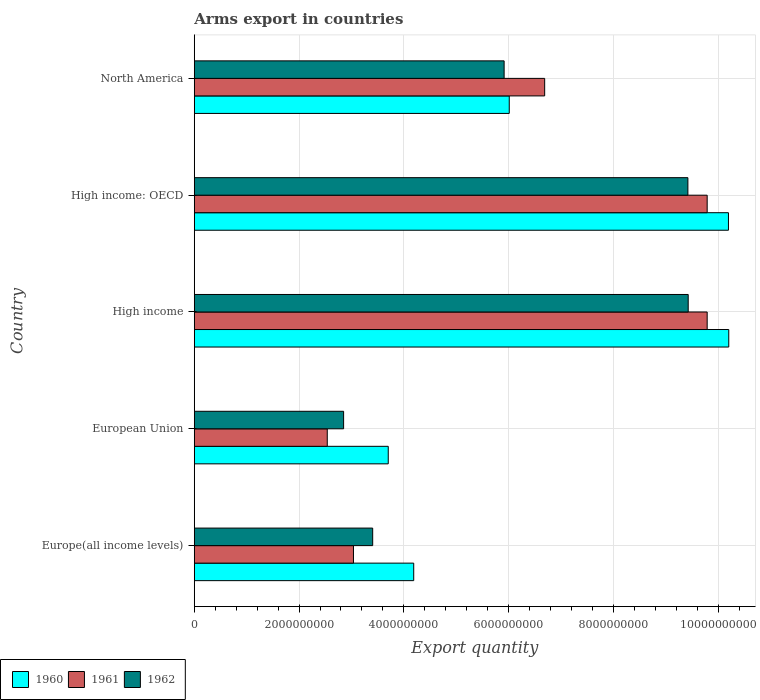How many groups of bars are there?
Your answer should be compact. 5. How many bars are there on the 1st tick from the top?
Your answer should be very brief. 3. What is the label of the 4th group of bars from the top?
Your response must be concise. European Union. In how many cases, is the number of bars for a given country not equal to the number of legend labels?
Keep it short and to the point. 0. What is the total arms export in 1962 in North America?
Provide a succinct answer. 5.91e+09. Across all countries, what is the maximum total arms export in 1961?
Your answer should be very brief. 9.79e+09. Across all countries, what is the minimum total arms export in 1961?
Provide a succinct answer. 2.54e+09. In which country was the total arms export in 1960 maximum?
Offer a terse response. High income. What is the total total arms export in 1962 in the graph?
Ensure brevity in your answer.  3.10e+1. What is the difference between the total arms export in 1960 in European Union and that in High income?
Offer a terse response. -6.50e+09. What is the difference between the total arms export in 1961 in Europe(all income levels) and the total arms export in 1960 in European Union?
Provide a succinct answer. -6.64e+08. What is the average total arms export in 1961 per country?
Ensure brevity in your answer.  6.37e+09. What is the difference between the total arms export in 1962 and total arms export in 1960 in Europe(all income levels)?
Offer a very short reply. -7.83e+08. What is the ratio of the total arms export in 1962 in European Union to that in High income?
Your answer should be very brief. 0.3. Is the difference between the total arms export in 1962 in Europe(all income levels) and High income: OECD greater than the difference between the total arms export in 1960 in Europe(all income levels) and High income: OECD?
Your response must be concise. No. What is the difference between the highest and the second highest total arms export in 1961?
Ensure brevity in your answer.  0. What is the difference between the highest and the lowest total arms export in 1960?
Ensure brevity in your answer.  6.50e+09. What does the 1st bar from the top in European Union represents?
Make the answer very short. 1962. What does the 1st bar from the bottom in European Union represents?
Your answer should be very brief. 1960. Is it the case that in every country, the sum of the total arms export in 1960 and total arms export in 1961 is greater than the total arms export in 1962?
Your response must be concise. Yes. How many bars are there?
Your answer should be compact. 15. Are all the bars in the graph horizontal?
Your answer should be very brief. Yes. What is the difference between two consecutive major ticks on the X-axis?
Your response must be concise. 2.00e+09. How are the legend labels stacked?
Your response must be concise. Horizontal. What is the title of the graph?
Provide a succinct answer. Arms export in countries. What is the label or title of the X-axis?
Offer a very short reply. Export quantity. What is the Export quantity in 1960 in Europe(all income levels)?
Make the answer very short. 4.19e+09. What is the Export quantity of 1961 in Europe(all income levels)?
Offer a terse response. 3.04e+09. What is the Export quantity of 1962 in Europe(all income levels)?
Offer a terse response. 3.40e+09. What is the Export quantity of 1960 in European Union?
Your answer should be compact. 3.70e+09. What is the Export quantity of 1961 in European Union?
Offer a very short reply. 2.54e+09. What is the Export quantity of 1962 in European Union?
Provide a succinct answer. 2.85e+09. What is the Export quantity in 1960 in High income?
Keep it short and to the point. 1.02e+1. What is the Export quantity of 1961 in High income?
Your answer should be very brief. 9.79e+09. What is the Export quantity in 1962 in High income?
Make the answer very short. 9.43e+09. What is the Export quantity of 1960 in High income: OECD?
Your response must be concise. 1.02e+1. What is the Export quantity in 1961 in High income: OECD?
Give a very brief answer. 9.79e+09. What is the Export quantity of 1962 in High income: OECD?
Your answer should be very brief. 9.42e+09. What is the Export quantity of 1960 in North America?
Your response must be concise. 6.01e+09. What is the Export quantity in 1961 in North America?
Your answer should be compact. 6.69e+09. What is the Export quantity in 1962 in North America?
Provide a succinct answer. 5.91e+09. Across all countries, what is the maximum Export quantity in 1960?
Keep it short and to the point. 1.02e+1. Across all countries, what is the maximum Export quantity in 1961?
Provide a short and direct response. 9.79e+09. Across all countries, what is the maximum Export quantity of 1962?
Your response must be concise. 9.43e+09. Across all countries, what is the minimum Export quantity in 1960?
Make the answer very short. 3.70e+09. Across all countries, what is the minimum Export quantity in 1961?
Provide a short and direct response. 2.54e+09. Across all countries, what is the minimum Export quantity in 1962?
Your answer should be very brief. 2.85e+09. What is the total Export quantity in 1960 in the graph?
Make the answer very short. 3.43e+1. What is the total Export quantity of 1961 in the graph?
Your response must be concise. 3.18e+1. What is the total Export quantity of 1962 in the graph?
Provide a short and direct response. 3.10e+1. What is the difference between the Export quantity in 1960 in Europe(all income levels) and that in European Union?
Ensure brevity in your answer.  4.86e+08. What is the difference between the Export quantity in 1962 in Europe(all income levels) and that in European Union?
Your answer should be very brief. 5.55e+08. What is the difference between the Export quantity in 1960 in Europe(all income levels) and that in High income?
Provide a succinct answer. -6.01e+09. What is the difference between the Export quantity of 1961 in Europe(all income levels) and that in High income?
Your answer should be compact. -6.75e+09. What is the difference between the Export quantity of 1962 in Europe(all income levels) and that in High income?
Give a very brief answer. -6.02e+09. What is the difference between the Export quantity in 1960 in Europe(all income levels) and that in High income: OECD?
Offer a very short reply. -6.01e+09. What is the difference between the Export quantity in 1961 in Europe(all income levels) and that in High income: OECD?
Your answer should be very brief. -6.75e+09. What is the difference between the Export quantity in 1962 in Europe(all income levels) and that in High income: OECD?
Your answer should be compact. -6.02e+09. What is the difference between the Export quantity in 1960 in Europe(all income levels) and that in North America?
Offer a terse response. -1.82e+09. What is the difference between the Export quantity in 1961 in Europe(all income levels) and that in North America?
Keep it short and to the point. -3.65e+09. What is the difference between the Export quantity of 1962 in Europe(all income levels) and that in North America?
Provide a short and direct response. -2.51e+09. What is the difference between the Export quantity in 1960 in European Union and that in High income?
Your response must be concise. -6.50e+09. What is the difference between the Export quantity of 1961 in European Union and that in High income?
Your answer should be compact. -7.25e+09. What is the difference between the Export quantity in 1962 in European Union and that in High income?
Your answer should be very brief. -6.58e+09. What is the difference between the Export quantity of 1960 in European Union and that in High income: OECD?
Your answer should be compact. -6.49e+09. What is the difference between the Export quantity in 1961 in European Union and that in High income: OECD?
Provide a short and direct response. -7.25e+09. What is the difference between the Export quantity in 1962 in European Union and that in High income: OECD?
Give a very brief answer. -6.57e+09. What is the difference between the Export quantity in 1960 in European Union and that in North America?
Provide a succinct answer. -2.31e+09. What is the difference between the Export quantity in 1961 in European Union and that in North America?
Your answer should be compact. -4.15e+09. What is the difference between the Export quantity of 1962 in European Union and that in North America?
Offer a very short reply. -3.06e+09. What is the difference between the Export quantity of 1960 in High income and that in High income: OECD?
Offer a terse response. 6.00e+06. What is the difference between the Export quantity of 1960 in High income and that in North America?
Your answer should be compact. 4.19e+09. What is the difference between the Export quantity of 1961 in High income and that in North America?
Offer a very short reply. 3.10e+09. What is the difference between the Export quantity of 1962 in High income and that in North America?
Your answer should be compact. 3.51e+09. What is the difference between the Export quantity in 1960 in High income: OECD and that in North America?
Give a very brief answer. 4.18e+09. What is the difference between the Export quantity in 1961 in High income: OECD and that in North America?
Keep it short and to the point. 3.10e+09. What is the difference between the Export quantity of 1962 in High income: OECD and that in North America?
Keep it short and to the point. 3.51e+09. What is the difference between the Export quantity in 1960 in Europe(all income levels) and the Export quantity in 1961 in European Union?
Your answer should be compact. 1.65e+09. What is the difference between the Export quantity of 1960 in Europe(all income levels) and the Export quantity of 1962 in European Union?
Provide a succinct answer. 1.34e+09. What is the difference between the Export quantity in 1961 in Europe(all income levels) and the Export quantity in 1962 in European Union?
Provide a short and direct response. 1.88e+08. What is the difference between the Export quantity of 1960 in Europe(all income levels) and the Export quantity of 1961 in High income?
Provide a succinct answer. -5.60e+09. What is the difference between the Export quantity of 1960 in Europe(all income levels) and the Export quantity of 1962 in High income?
Keep it short and to the point. -5.24e+09. What is the difference between the Export quantity of 1961 in Europe(all income levels) and the Export quantity of 1962 in High income?
Offer a terse response. -6.39e+09. What is the difference between the Export quantity of 1960 in Europe(all income levels) and the Export quantity of 1961 in High income: OECD?
Your answer should be compact. -5.60e+09. What is the difference between the Export quantity of 1960 in Europe(all income levels) and the Export quantity of 1962 in High income: OECD?
Offer a terse response. -5.23e+09. What is the difference between the Export quantity of 1961 in Europe(all income levels) and the Export quantity of 1962 in High income: OECD?
Your answer should be compact. -6.38e+09. What is the difference between the Export quantity in 1960 in Europe(all income levels) and the Export quantity in 1961 in North America?
Ensure brevity in your answer.  -2.50e+09. What is the difference between the Export quantity in 1960 in Europe(all income levels) and the Export quantity in 1962 in North America?
Your answer should be very brief. -1.72e+09. What is the difference between the Export quantity in 1961 in Europe(all income levels) and the Export quantity in 1962 in North America?
Provide a short and direct response. -2.88e+09. What is the difference between the Export quantity of 1960 in European Union and the Export quantity of 1961 in High income?
Your answer should be compact. -6.09e+09. What is the difference between the Export quantity in 1960 in European Union and the Export quantity in 1962 in High income?
Provide a short and direct response. -5.72e+09. What is the difference between the Export quantity of 1961 in European Union and the Export quantity of 1962 in High income?
Your answer should be very brief. -6.89e+09. What is the difference between the Export quantity in 1960 in European Union and the Export quantity in 1961 in High income: OECD?
Offer a very short reply. -6.09e+09. What is the difference between the Export quantity of 1960 in European Union and the Export quantity of 1962 in High income: OECD?
Provide a succinct answer. -5.72e+09. What is the difference between the Export quantity of 1961 in European Union and the Export quantity of 1962 in High income: OECD?
Offer a terse response. -6.88e+09. What is the difference between the Export quantity of 1960 in European Union and the Export quantity of 1961 in North America?
Your answer should be compact. -2.98e+09. What is the difference between the Export quantity in 1960 in European Union and the Export quantity in 1962 in North America?
Keep it short and to the point. -2.21e+09. What is the difference between the Export quantity of 1961 in European Union and the Export quantity of 1962 in North America?
Offer a very short reply. -3.38e+09. What is the difference between the Export quantity of 1960 in High income and the Export quantity of 1961 in High income: OECD?
Keep it short and to the point. 4.12e+08. What is the difference between the Export quantity in 1960 in High income and the Export quantity in 1962 in High income: OECD?
Provide a short and direct response. 7.80e+08. What is the difference between the Export quantity of 1961 in High income and the Export quantity of 1962 in High income: OECD?
Offer a very short reply. 3.68e+08. What is the difference between the Export quantity of 1960 in High income and the Export quantity of 1961 in North America?
Your answer should be very brief. 3.51e+09. What is the difference between the Export quantity of 1960 in High income and the Export quantity of 1962 in North America?
Ensure brevity in your answer.  4.29e+09. What is the difference between the Export quantity in 1961 in High income and the Export quantity in 1962 in North America?
Provide a succinct answer. 3.88e+09. What is the difference between the Export quantity in 1960 in High income: OECD and the Export quantity in 1961 in North America?
Your answer should be compact. 3.51e+09. What is the difference between the Export quantity in 1960 in High income: OECD and the Export quantity in 1962 in North America?
Make the answer very short. 4.28e+09. What is the difference between the Export quantity of 1961 in High income: OECD and the Export quantity of 1962 in North America?
Make the answer very short. 3.88e+09. What is the average Export quantity of 1960 per country?
Your response must be concise. 6.86e+09. What is the average Export quantity of 1961 per country?
Your response must be concise. 6.37e+09. What is the average Export quantity of 1962 per country?
Your answer should be very brief. 6.20e+09. What is the difference between the Export quantity of 1960 and Export quantity of 1961 in Europe(all income levels)?
Offer a terse response. 1.15e+09. What is the difference between the Export quantity in 1960 and Export quantity in 1962 in Europe(all income levels)?
Your answer should be very brief. 7.83e+08. What is the difference between the Export quantity in 1961 and Export quantity in 1962 in Europe(all income levels)?
Keep it short and to the point. -3.67e+08. What is the difference between the Export quantity in 1960 and Export quantity in 1961 in European Union?
Ensure brevity in your answer.  1.16e+09. What is the difference between the Export quantity of 1960 and Export quantity of 1962 in European Union?
Ensure brevity in your answer.  8.52e+08. What is the difference between the Export quantity of 1961 and Export quantity of 1962 in European Union?
Your answer should be compact. -3.12e+08. What is the difference between the Export quantity in 1960 and Export quantity in 1961 in High income?
Make the answer very short. 4.12e+08. What is the difference between the Export quantity in 1960 and Export quantity in 1962 in High income?
Give a very brief answer. 7.74e+08. What is the difference between the Export quantity of 1961 and Export quantity of 1962 in High income?
Offer a very short reply. 3.62e+08. What is the difference between the Export quantity in 1960 and Export quantity in 1961 in High income: OECD?
Make the answer very short. 4.06e+08. What is the difference between the Export quantity in 1960 and Export quantity in 1962 in High income: OECD?
Provide a short and direct response. 7.74e+08. What is the difference between the Export quantity of 1961 and Export quantity of 1962 in High income: OECD?
Ensure brevity in your answer.  3.68e+08. What is the difference between the Export quantity in 1960 and Export quantity in 1961 in North America?
Your answer should be compact. -6.76e+08. What is the difference between the Export quantity in 1960 and Export quantity in 1962 in North America?
Your response must be concise. 9.80e+07. What is the difference between the Export quantity in 1961 and Export quantity in 1962 in North America?
Your response must be concise. 7.74e+08. What is the ratio of the Export quantity of 1960 in Europe(all income levels) to that in European Union?
Your answer should be very brief. 1.13. What is the ratio of the Export quantity of 1961 in Europe(all income levels) to that in European Union?
Make the answer very short. 1.2. What is the ratio of the Export quantity in 1962 in Europe(all income levels) to that in European Union?
Your answer should be compact. 1.19. What is the ratio of the Export quantity of 1960 in Europe(all income levels) to that in High income?
Your answer should be compact. 0.41. What is the ratio of the Export quantity of 1961 in Europe(all income levels) to that in High income?
Your answer should be very brief. 0.31. What is the ratio of the Export quantity in 1962 in Europe(all income levels) to that in High income?
Provide a short and direct response. 0.36. What is the ratio of the Export quantity of 1960 in Europe(all income levels) to that in High income: OECD?
Ensure brevity in your answer.  0.41. What is the ratio of the Export quantity of 1961 in Europe(all income levels) to that in High income: OECD?
Make the answer very short. 0.31. What is the ratio of the Export quantity of 1962 in Europe(all income levels) to that in High income: OECD?
Make the answer very short. 0.36. What is the ratio of the Export quantity in 1960 in Europe(all income levels) to that in North America?
Your answer should be very brief. 0.7. What is the ratio of the Export quantity in 1961 in Europe(all income levels) to that in North America?
Your answer should be compact. 0.45. What is the ratio of the Export quantity in 1962 in Europe(all income levels) to that in North America?
Your answer should be very brief. 0.58. What is the ratio of the Export quantity of 1960 in European Union to that in High income?
Provide a succinct answer. 0.36. What is the ratio of the Export quantity of 1961 in European Union to that in High income?
Your answer should be compact. 0.26. What is the ratio of the Export quantity in 1962 in European Union to that in High income?
Your response must be concise. 0.3. What is the ratio of the Export quantity of 1960 in European Union to that in High income: OECD?
Provide a succinct answer. 0.36. What is the ratio of the Export quantity of 1961 in European Union to that in High income: OECD?
Provide a short and direct response. 0.26. What is the ratio of the Export quantity of 1962 in European Union to that in High income: OECD?
Give a very brief answer. 0.3. What is the ratio of the Export quantity of 1960 in European Union to that in North America?
Provide a short and direct response. 0.62. What is the ratio of the Export quantity in 1961 in European Union to that in North America?
Ensure brevity in your answer.  0.38. What is the ratio of the Export quantity of 1962 in European Union to that in North America?
Your answer should be compact. 0.48. What is the ratio of the Export quantity of 1960 in High income to that in High income: OECD?
Offer a very short reply. 1. What is the ratio of the Export quantity of 1960 in High income to that in North America?
Your answer should be very brief. 1.7. What is the ratio of the Export quantity in 1961 in High income to that in North America?
Provide a short and direct response. 1.46. What is the ratio of the Export quantity in 1962 in High income to that in North America?
Ensure brevity in your answer.  1.59. What is the ratio of the Export quantity in 1960 in High income: OECD to that in North America?
Your response must be concise. 1.7. What is the ratio of the Export quantity of 1961 in High income: OECD to that in North America?
Offer a very short reply. 1.46. What is the ratio of the Export quantity of 1962 in High income: OECD to that in North America?
Your response must be concise. 1.59. What is the difference between the highest and the second highest Export quantity of 1961?
Give a very brief answer. 0. What is the difference between the highest and the lowest Export quantity of 1960?
Your response must be concise. 6.50e+09. What is the difference between the highest and the lowest Export quantity in 1961?
Provide a succinct answer. 7.25e+09. What is the difference between the highest and the lowest Export quantity of 1962?
Offer a very short reply. 6.58e+09. 